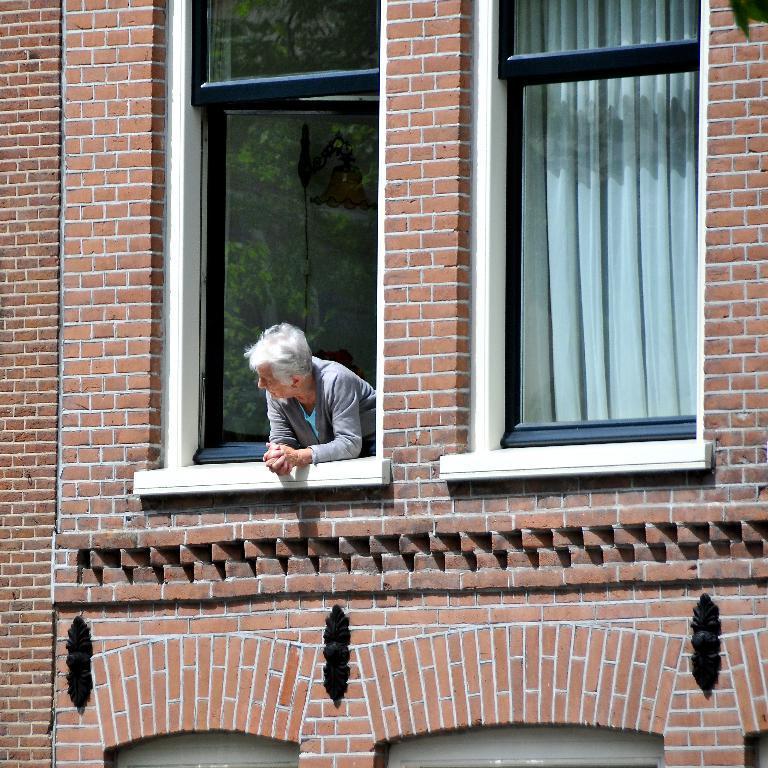In one or two sentences, can you explain what this image depicts? As we can see in the image there is a building, windows, curtain and a person standing over here. 